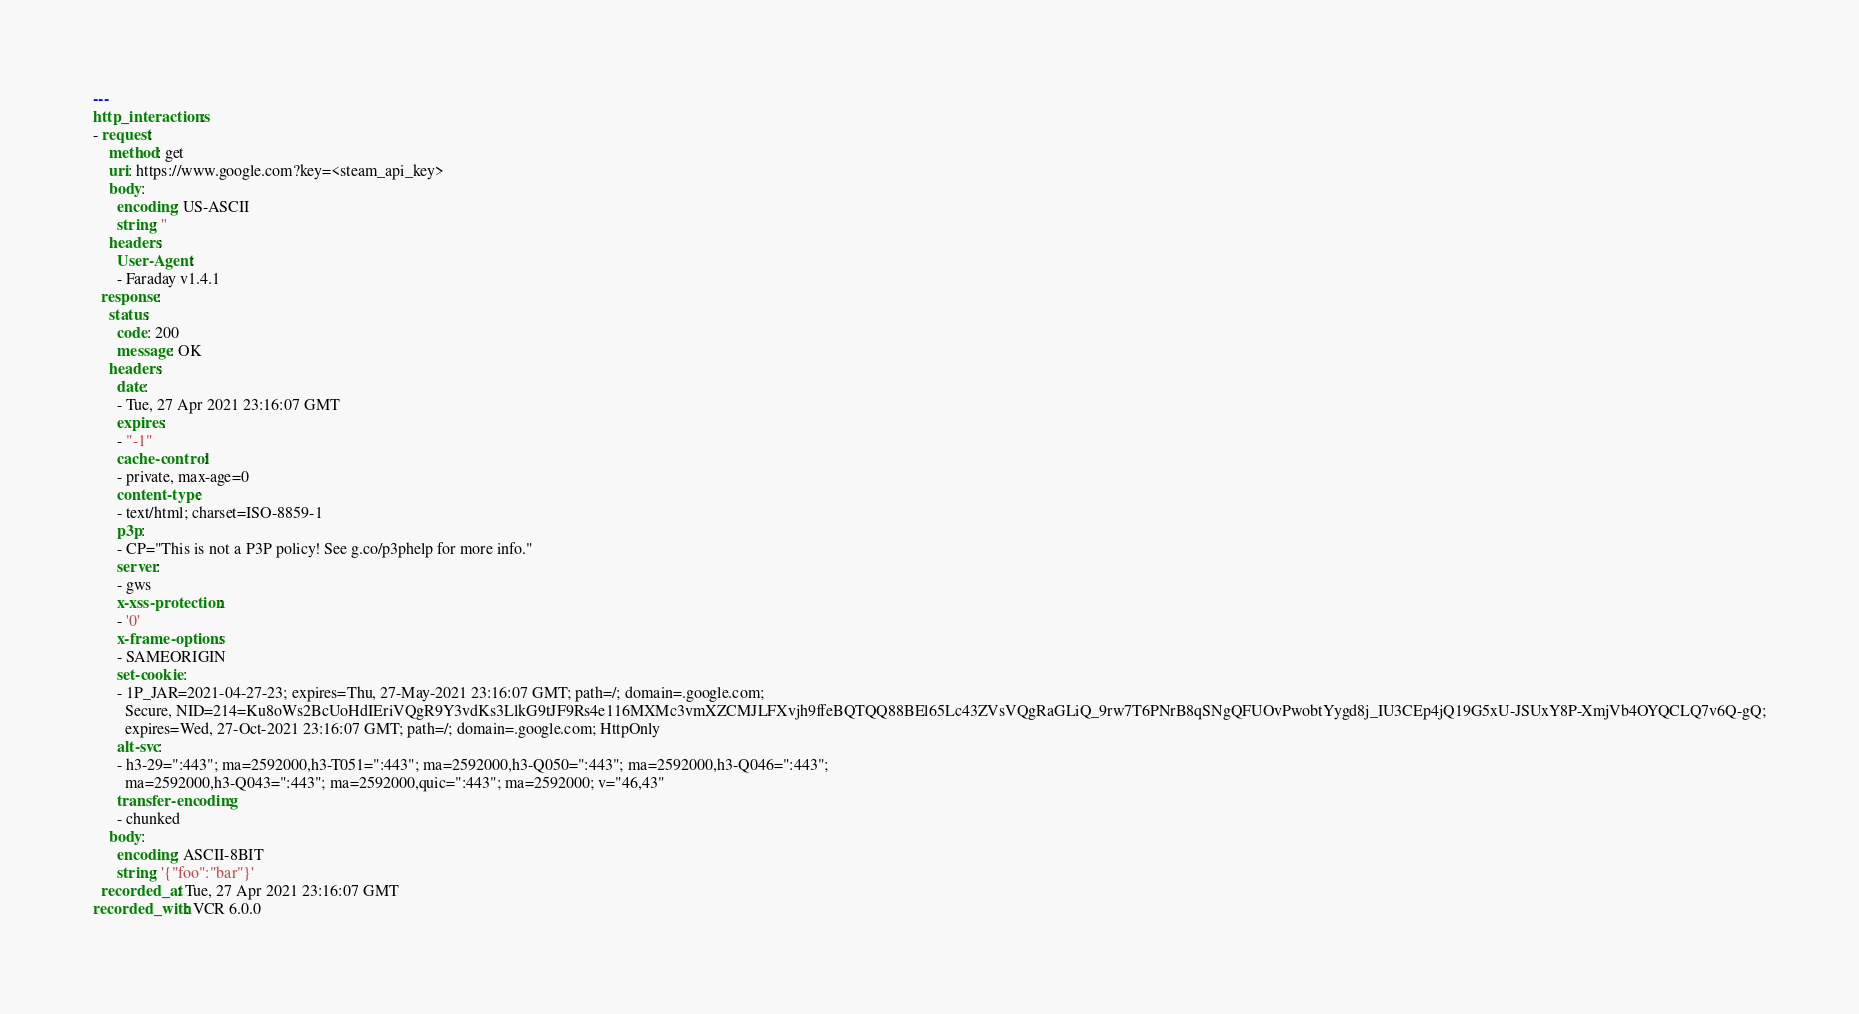Convert code to text. <code><loc_0><loc_0><loc_500><loc_500><_YAML_>---
http_interactions:
- request:
    method: get
    uri: https://www.google.com?key=<steam_api_key>
    body:
      encoding: US-ASCII
      string: ''
    headers:
      User-Agent:
      - Faraday v1.4.1
  response:
    status:
      code: 200
      message: OK
    headers:
      date:
      - Tue, 27 Apr 2021 23:16:07 GMT
      expires:
      - "-1"
      cache-control:
      - private, max-age=0
      content-type:
      - text/html; charset=ISO-8859-1
      p3p:
      - CP="This is not a P3P policy! See g.co/p3phelp for more info."
      server:
      - gws
      x-xss-protection:
      - '0'
      x-frame-options:
      - SAMEORIGIN
      set-cookie:
      - 1P_JAR=2021-04-27-23; expires=Thu, 27-May-2021 23:16:07 GMT; path=/; domain=.google.com;
        Secure, NID=214=Ku8oWs2BcUoHdIEriVQgR9Y3vdKs3LlkG9tJF9Rs4e116MXMc3vmXZCMJLFXvjh9ffeBQTQQ88BEl65Lc43ZVsVQgRaGLiQ_9rw7T6PNrB8qSNgQFUOvPwobtYygd8j_IU3CEp4jQ19G5xU-JSUxY8P-XmjVb4OYQCLQ7v6Q-gQ;
        expires=Wed, 27-Oct-2021 23:16:07 GMT; path=/; domain=.google.com; HttpOnly
      alt-svc:
      - h3-29=":443"; ma=2592000,h3-T051=":443"; ma=2592000,h3-Q050=":443"; ma=2592000,h3-Q046=":443";
        ma=2592000,h3-Q043=":443"; ma=2592000,quic=":443"; ma=2592000; v="46,43"
      transfer-encoding:
      - chunked
    body:
      encoding: ASCII-8BIT
      string: '{"foo":"bar"}'
  recorded_at: Tue, 27 Apr 2021 23:16:07 GMT
recorded_with: VCR 6.0.0
</code> 